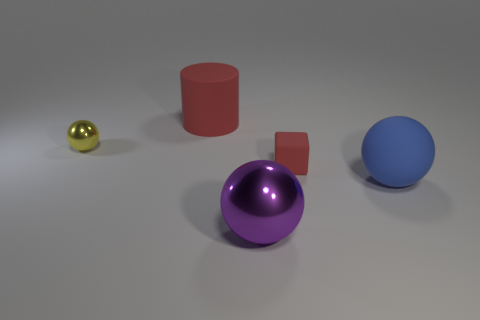Is there anything else that is the same shape as the small red thing?
Offer a terse response. No. What is the material of the small thing that is to the right of the ball to the left of the big ball on the left side of the large blue matte object?
Provide a short and direct response. Rubber. Is there a ball of the same size as the rubber block?
Your answer should be compact. Yes. The large thing that is behind the large ball on the right side of the purple thing is what color?
Your answer should be very brief. Red. What number of large things are there?
Offer a terse response. 3. Is the large matte sphere the same color as the matte cylinder?
Your answer should be compact. No. Are there fewer big blue objects on the left side of the rubber ball than big red rubber things behind the small metallic thing?
Offer a terse response. Yes. The rubber cylinder has what color?
Keep it short and to the point. Red. What number of cylinders have the same color as the tiny matte cube?
Give a very brief answer. 1. Are there any big blue things left of the large metal ball?
Provide a succinct answer. No. 